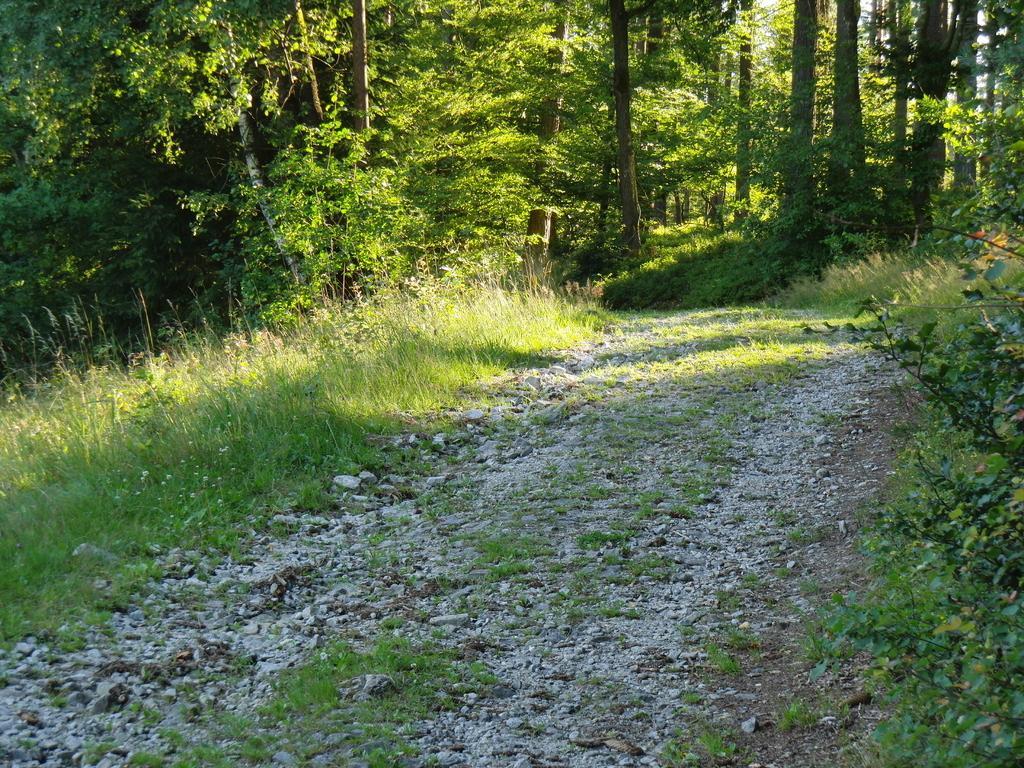In one or two sentences, can you explain what this image depicts? In this image there is some grass and rocks on the path. Background there are plants and trees. 